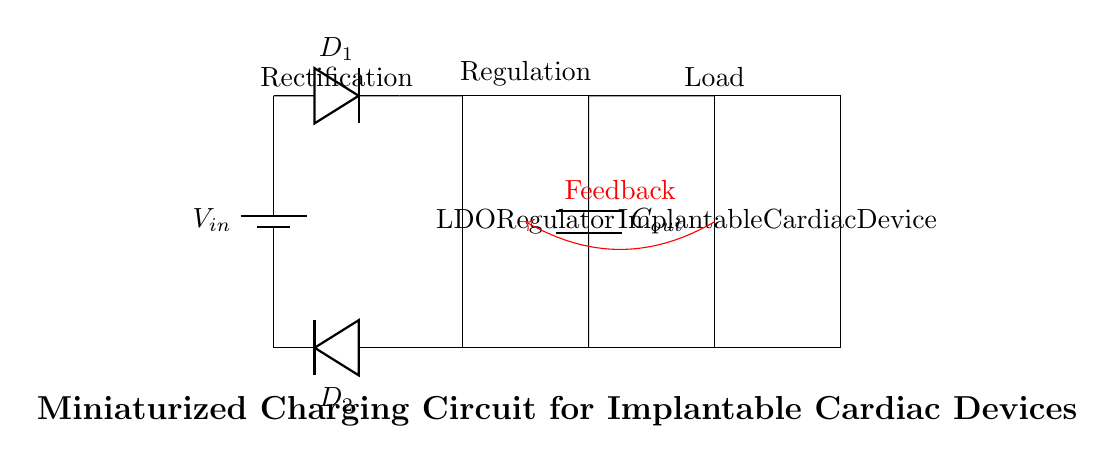What is the input component of the circuit? The input component is a battery, which provides the voltage supply to the circuit. It is represented by the symbol for a battery labeled with Vin.
Answer: battery What type of rectification is used in this circuit? This circuit uses diode-based rectification, indicated by the diodes showing current flow direction and their positioning.
Answer: diode What is the role of the LDO regulator? The LDO regulator stabilizes the output voltage, ensuring the implantable cardiac device receives a consistent voltage. It's located between the input and output stages.
Answer: voltage stabilization How many diodes are present in the circuit? Two diodes are present, shown at the rectifier stage of the circuit connecting the battery to the output through the LDO regulator.
Answer: two What is the component labeled Cout? Cout represents an output capacitor, which filters the output voltage to provide a smoother and more stable voltage supply to the load (the implantable device).
Answer: output capacitor What is the feedback loop connected to? The feedback loop is connected to the implantable cardiac device, allowing the circuit to adjust based on the load conditions, ensuring efficiency.
Answer: implantable cardiac device What does the red arrow signify? The red arrow signifies the feedback mechanism in the circuit, which is crucial for regulating the output voltage based on the performance of the load.
Answer: feedback 